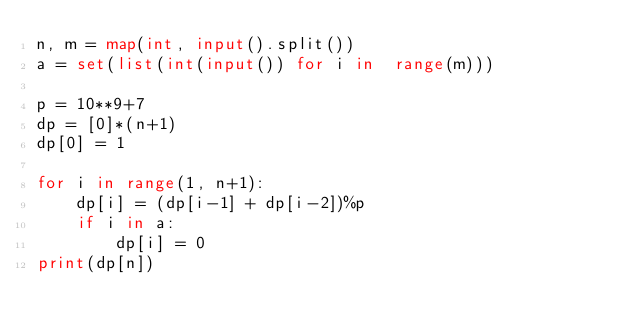<code> <loc_0><loc_0><loc_500><loc_500><_Python_>n, m = map(int, input().split())
a = set(list(int(input()) for i in  range(m)))

p = 10**9+7
dp = [0]*(n+1)
dp[0] = 1

for i in range(1, n+1):
    dp[i] = (dp[i-1] + dp[i-2])%p
    if i in a:
        dp[i] = 0
print(dp[n])

</code> 